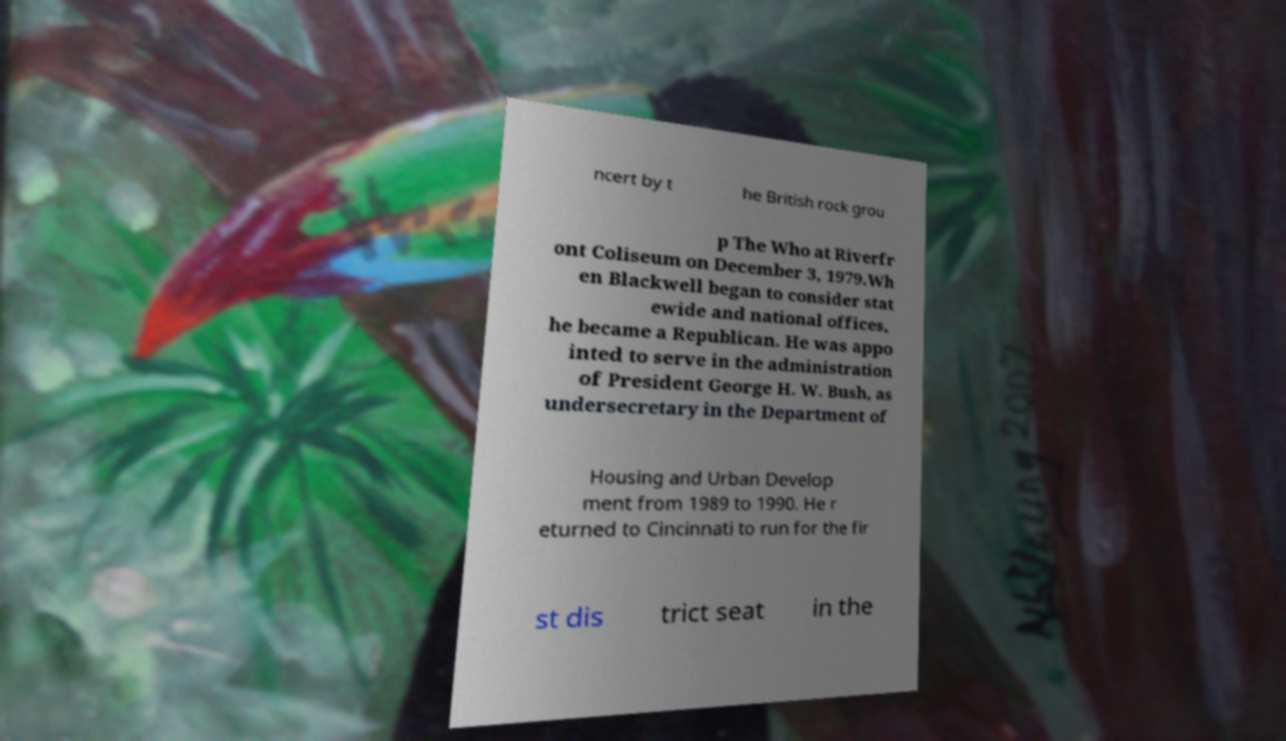Could you assist in decoding the text presented in this image and type it out clearly? ncert by t he British rock grou p The Who at Riverfr ont Coliseum on December 3, 1979.Wh en Blackwell began to consider stat ewide and national offices, he became a Republican. He was appo inted to serve in the administration of President George H. W. Bush, as undersecretary in the Department of Housing and Urban Develop ment from 1989 to 1990. He r eturned to Cincinnati to run for the fir st dis trict seat in the 